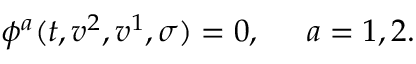Convert formula to latex. <formula><loc_0><loc_0><loc_500><loc_500>\phi ^ { a } ( t , v ^ { 2 } , v ^ { 1 } , \sigma ) = 0 , \ \, a = 1 , 2 .</formula> 